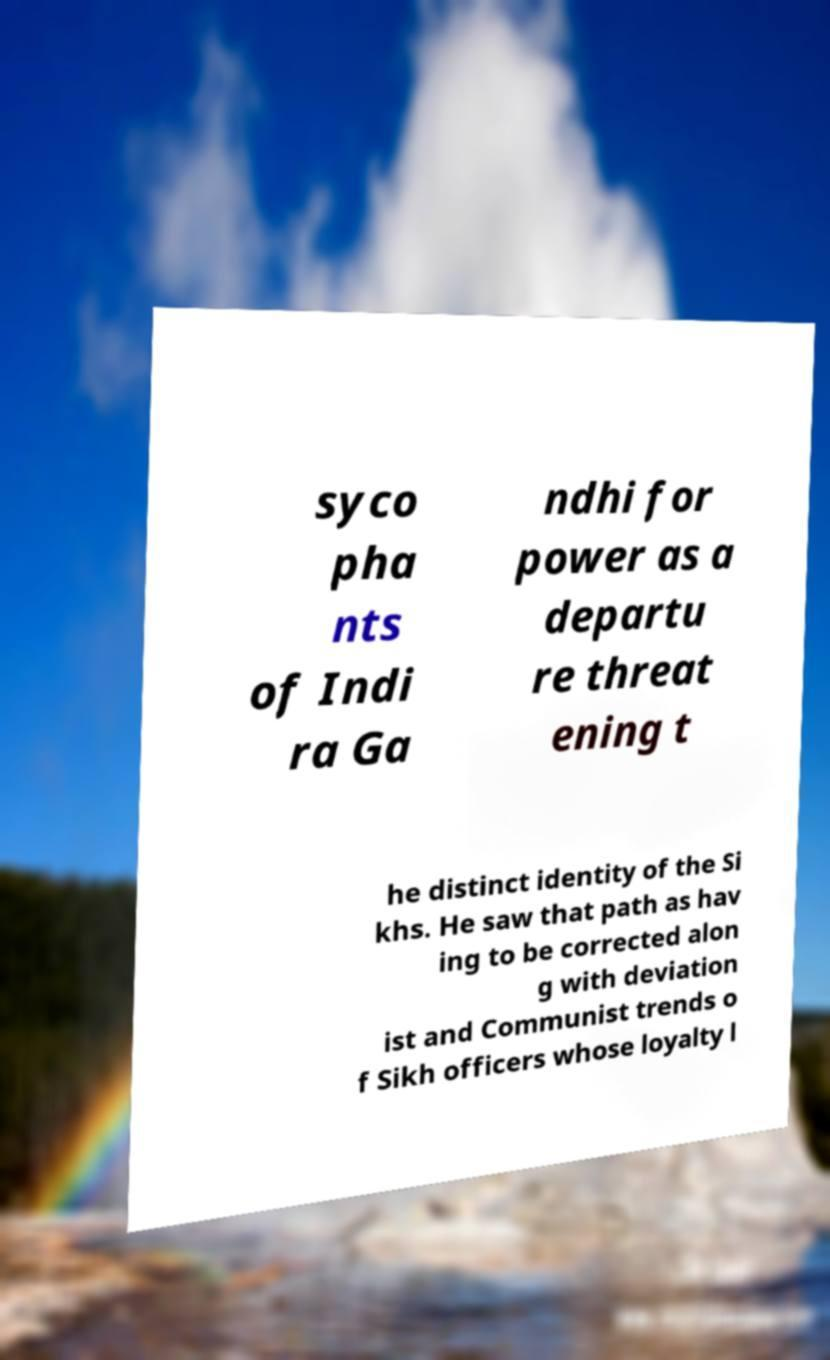I need the written content from this picture converted into text. Can you do that? syco pha nts of Indi ra Ga ndhi for power as a departu re threat ening t he distinct identity of the Si khs. He saw that path as hav ing to be corrected alon g with deviation ist and Communist trends o f Sikh officers whose loyalty l 